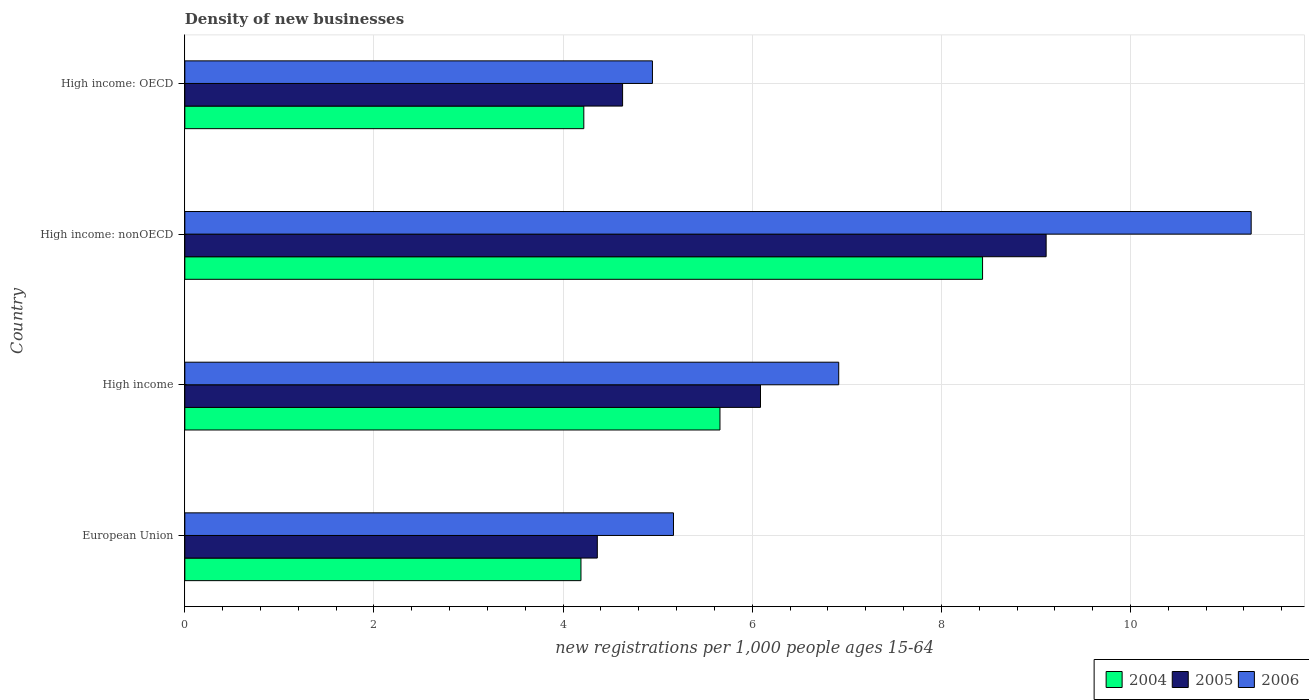Are the number of bars per tick equal to the number of legend labels?
Offer a very short reply. Yes. Are the number of bars on each tick of the Y-axis equal?
Keep it short and to the point. Yes. How many bars are there on the 1st tick from the top?
Provide a short and direct response. 3. What is the label of the 4th group of bars from the top?
Your answer should be very brief. European Union. In how many cases, is the number of bars for a given country not equal to the number of legend labels?
Your answer should be very brief. 0. What is the number of new registrations in 2006 in High income: OECD?
Offer a terse response. 4.94. Across all countries, what is the maximum number of new registrations in 2004?
Give a very brief answer. 8.44. Across all countries, what is the minimum number of new registrations in 2005?
Keep it short and to the point. 4.36. In which country was the number of new registrations in 2004 maximum?
Offer a very short reply. High income: nonOECD. In which country was the number of new registrations in 2004 minimum?
Your answer should be very brief. European Union. What is the total number of new registrations in 2004 in the graph?
Offer a terse response. 22.5. What is the difference between the number of new registrations in 2006 in European Union and that in High income: nonOECD?
Ensure brevity in your answer.  -6.11. What is the difference between the number of new registrations in 2004 in High income: OECD and the number of new registrations in 2005 in High income: nonOECD?
Make the answer very short. -4.89. What is the average number of new registrations in 2004 per country?
Offer a terse response. 5.63. What is the difference between the number of new registrations in 2006 and number of new registrations in 2005 in High income?
Your answer should be compact. 0.83. What is the ratio of the number of new registrations in 2005 in European Union to that in High income: OECD?
Ensure brevity in your answer.  0.94. Is the number of new registrations in 2004 in High income: OECD less than that in High income: nonOECD?
Ensure brevity in your answer.  Yes. What is the difference between the highest and the second highest number of new registrations in 2006?
Ensure brevity in your answer.  4.36. What is the difference between the highest and the lowest number of new registrations in 2006?
Your answer should be compact. 6.33. How many bars are there?
Offer a terse response. 12. Does the graph contain any zero values?
Ensure brevity in your answer.  No. How many legend labels are there?
Offer a terse response. 3. What is the title of the graph?
Give a very brief answer. Density of new businesses. Does "1963" appear as one of the legend labels in the graph?
Offer a terse response. No. What is the label or title of the X-axis?
Provide a short and direct response. New registrations per 1,0 people ages 15-64. What is the new registrations per 1,000 people ages 15-64 in 2004 in European Union?
Your response must be concise. 4.19. What is the new registrations per 1,000 people ages 15-64 in 2005 in European Union?
Provide a short and direct response. 4.36. What is the new registrations per 1,000 people ages 15-64 of 2006 in European Union?
Your answer should be very brief. 5.17. What is the new registrations per 1,000 people ages 15-64 of 2004 in High income?
Your answer should be very brief. 5.66. What is the new registrations per 1,000 people ages 15-64 of 2005 in High income?
Keep it short and to the point. 6.09. What is the new registrations per 1,000 people ages 15-64 in 2006 in High income?
Ensure brevity in your answer.  6.91. What is the new registrations per 1,000 people ages 15-64 of 2004 in High income: nonOECD?
Ensure brevity in your answer.  8.44. What is the new registrations per 1,000 people ages 15-64 of 2005 in High income: nonOECD?
Your response must be concise. 9.11. What is the new registrations per 1,000 people ages 15-64 in 2006 in High income: nonOECD?
Your answer should be compact. 11.28. What is the new registrations per 1,000 people ages 15-64 of 2004 in High income: OECD?
Give a very brief answer. 4.22. What is the new registrations per 1,000 people ages 15-64 of 2005 in High income: OECD?
Your answer should be very brief. 4.63. What is the new registrations per 1,000 people ages 15-64 in 2006 in High income: OECD?
Keep it short and to the point. 4.94. Across all countries, what is the maximum new registrations per 1,000 people ages 15-64 in 2004?
Your answer should be very brief. 8.44. Across all countries, what is the maximum new registrations per 1,000 people ages 15-64 in 2005?
Make the answer very short. 9.11. Across all countries, what is the maximum new registrations per 1,000 people ages 15-64 of 2006?
Provide a short and direct response. 11.28. Across all countries, what is the minimum new registrations per 1,000 people ages 15-64 in 2004?
Provide a succinct answer. 4.19. Across all countries, what is the minimum new registrations per 1,000 people ages 15-64 of 2005?
Make the answer very short. 4.36. Across all countries, what is the minimum new registrations per 1,000 people ages 15-64 of 2006?
Make the answer very short. 4.94. What is the total new registrations per 1,000 people ages 15-64 in 2004 in the graph?
Give a very brief answer. 22.5. What is the total new registrations per 1,000 people ages 15-64 of 2005 in the graph?
Provide a short and direct response. 24.19. What is the total new registrations per 1,000 people ages 15-64 of 2006 in the graph?
Provide a succinct answer. 28.3. What is the difference between the new registrations per 1,000 people ages 15-64 in 2004 in European Union and that in High income?
Your response must be concise. -1.47. What is the difference between the new registrations per 1,000 people ages 15-64 in 2005 in European Union and that in High income?
Provide a short and direct response. -1.73. What is the difference between the new registrations per 1,000 people ages 15-64 of 2006 in European Union and that in High income?
Give a very brief answer. -1.75. What is the difference between the new registrations per 1,000 people ages 15-64 of 2004 in European Union and that in High income: nonOECD?
Your answer should be compact. -4.25. What is the difference between the new registrations per 1,000 people ages 15-64 in 2005 in European Union and that in High income: nonOECD?
Offer a very short reply. -4.75. What is the difference between the new registrations per 1,000 people ages 15-64 of 2006 in European Union and that in High income: nonOECD?
Your answer should be compact. -6.11. What is the difference between the new registrations per 1,000 people ages 15-64 of 2004 in European Union and that in High income: OECD?
Make the answer very short. -0.03. What is the difference between the new registrations per 1,000 people ages 15-64 in 2005 in European Union and that in High income: OECD?
Keep it short and to the point. -0.27. What is the difference between the new registrations per 1,000 people ages 15-64 of 2006 in European Union and that in High income: OECD?
Your response must be concise. 0.22. What is the difference between the new registrations per 1,000 people ages 15-64 in 2004 in High income and that in High income: nonOECD?
Ensure brevity in your answer.  -2.78. What is the difference between the new registrations per 1,000 people ages 15-64 in 2005 in High income and that in High income: nonOECD?
Make the answer very short. -3.02. What is the difference between the new registrations per 1,000 people ages 15-64 in 2006 in High income and that in High income: nonOECD?
Give a very brief answer. -4.36. What is the difference between the new registrations per 1,000 people ages 15-64 of 2004 in High income and that in High income: OECD?
Offer a terse response. 1.44. What is the difference between the new registrations per 1,000 people ages 15-64 of 2005 in High income and that in High income: OECD?
Give a very brief answer. 1.46. What is the difference between the new registrations per 1,000 people ages 15-64 in 2006 in High income and that in High income: OECD?
Give a very brief answer. 1.97. What is the difference between the new registrations per 1,000 people ages 15-64 of 2004 in High income: nonOECD and that in High income: OECD?
Provide a short and direct response. 4.22. What is the difference between the new registrations per 1,000 people ages 15-64 in 2005 in High income: nonOECD and that in High income: OECD?
Offer a terse response. 4.48. What is the difference between the new registrations per 1,000 people ages 15-64 of 2006 in High income: nonOECD and that in High income: OECD?
Your answer should be very brief. 6.33. What is the difference between the new registrations per 1,000 people ages 15-64 of 2004 in European Union and the new registrations per 1,000 people ages 15-64 of 2005 in High income?
Provide a short and direct response. -1.9. What is the difference between the new registrations per 1,000 people ages 15-64 in 2004 in European Union and the new registrations per 1,000 people ages 15-64 in 2006 in High income?
Offer a very short reply. -2.73. What is the difference between the new registrations per 1,000 people ages 15-64 of 2005 in European Union and the new registrations per 1,000 people ages 15-64 of 2006 in High income?
Provide a succinct answer. -2.55. What is the difference between the new registrations per 1,000 people ages 15-64 of 2004 in European Union and the new registrations per 1,000 people ages 15-64 of 2005 in High income: nonOECD?
Your answer should be very brief. -4.92. What is the difference between the new registrations per 1,000 people ages 15-64 of 2004 in European Union and the new registrations per 1,000 people ages 15-64 of 2006 in High income: nonOECD?
Provide a succinct answer. -7.09. What is the difference between the new registrations per 1,000 people ages 15-64 in 2005 in European Union and the new registrations per 1,000 people ages 15-64 in 2006 in High income: nonOECD?
Provide a succinct answer. -6.91. What is the difference between the new registrations per 1,000 people ages 15-64 in 2004 in European Union and the new registrations per 1,000 people ages 15-64 in 2005 in High income: OECD?
Ensure brevity in your answer.  -0.44. What is the difference between the new registrations per 1,000 people ages 15-64 in 2004 in European Union and the new registrations per 1,000 people ages 15-64 in 2006 in High income: OECD?
Provide a short and direct response. -0.76. What is the difference between the new registrations per 1,000 people ages 15-64 in 2005 in European Union and the new registrations per 1,000 people ages 15-64 in 2006 in High income: OECD?
Your answer should be very brief. -0.58. What is the difference between the new registrations per 1,000 people ages 15-64 of 2004 in High income and the new registrations per 1,000 people ages 15-64 of 2005 in High income: nonOECD?
Your answer should be very brief. -3.45. What is the difference between the new registrations per 1,000 people ages 15-64 in 2004 in High income and the new registrations per 1,000 people ages 15-64 in 2006 in High income: nonOECD?
Your answer should be compact. -5.62. What is the difference between the new registrations per 1,000 people ages 15-64 of 2005 in High income and the new registrations per 1,000 people ages 15-64 of 2006 in High income: nonOECD?
Keep it short and to the point. -5.19. What is the difference between the new registrations per 1,000 people ages 15-64 of 2004 in High income and the new registrations per 1,000 people ages 15-64 of 2005 in High income: OECD?
Keep it short and to the point. 1.03. What is the difference between the new registrations per 1,000 people ages 15-64 in 2004 in High income and the new registrations per 1,000 people ages 15-64 in 2006 in High income: OECD?
Offer a terse response. 0.71. What is the difference between the new registrations per 1,000 people ages 15-64 of 2005 in High income and the new registrations per 1,000 people ages 15-64 of 2006 in High income: OECD?
Give a very brief answer. 1.14. What is the difference between the new registrations per 1,000 people ages 15-64 in 2004 in High income: nonOECD and the new registrations per 1,000 people ages 15-64 in 2005 in High income: OECD?
Your response must be concise. 3.81. What is the difference between the new registrations per 1,000 people ages 15-64 in 2004 in High income: nonOECD and the new registrations per 1,000 people ages 15-64 in 2006 in High income: OECD?
Make the answer very short. 3.49. What is the difference between the new registrations per 1,000 people ages 15-64 in 2005 in High income: nonOECD and the new registrations per 1,000 people ages 15-64 in 2006 in High income: OECD?
Offer a very short reply. 4.16. What is the average new registrations per 1,000 people ages 15-64 in 2004 per country?
Your answer should be compact. 5.63. What is the average new registrations per 1,000 people ages 15-64 of 2005 per country?
Offer a very short reply. 6.05. What is the average new registrations per 1,000 people ages 15-64 of 2006 per country?
Keep it short and to the point. 7.08. What is the difference between the new registrations per 1,000 people ages 15-64 in 2004 and new registrations per 1,000 people ages 15-64 in 2005 in European Union?
Give a very brief answer. -0.17. What is the difference between the new registrations per 1,000 people ages 15-64 in 2004 and new registrations per 1,000 people ages 15-64 in 2006 in European Union?
Offer a terse response. -0.98. What is the difference between the new registrations per 1,000 people ages 15-64 of 2005 and new registrations per 1,000 people ages 15-64 of 2006 in European Union?
Offer a very short reply. -0.81. What is the difference between the new registrations per 1,000 people ages 15-64 of 2004 and new registrations per 1,000 people ages 15-64 of 2005 in High income?
Offer a terse response. -0.43. What is the difference between the new registrations per 1,000 people ages 15-64 in 2004 and new registrations per 1,000 people ages 15-64 in 2006 in High income?
Provide a succinct answer. -1.26. What is the difference between the new registrations per 1,000 people ages 15-64 of 2005 and new registrations per 1,000 people ages 15-64 of 2006 in High income?
Provide a short and direct response. -0.83. What is the difference between the new registrations per 1,000 people ages 15-64 of 2004 and new registrations per 1,000 people ages 15-64 of 2005 in High income: nonOECD?
Your answer should be compact. -0.67. What is the difference between the new registrations per 1,000 people ages 15-64 of 2004 and new registrations per 1,000 people ages 15-64 of 2006 in High income: nonOECD?
Your response must be concise. -2.84. What is the difference between the new registrations per 1,000 people ages 15-64 in 2005 and new registrations per 1,000 people ages 15-64 in 2006 in High income: nonOECD?
Keep it short and to the point. -2.17. What is the difference between the new registrations per 1,000 people ages 15-64 in 2004 and new registrations per 1,000 people ages 15-64 in 2005 in High income: OECD?
Keep it short and to the point. -0.41. What is the difference between the new registrations per 1,000 people ages 15-64 of 2004 and new registrations per 1,000 people ages 15-64 of 2006 in High income: OECD?
Make the answer very short. -0.73. What is the difference between the new registrations per 1,000 people ages 15-64 in 2005 and new registrations per 1,000 people ages 15-64 in 2006 in High income: OECD?
Your answer should be very brief. -0.32. What is the ratio of the new registrations per 1,000 people ages 15-64 of 2004 in European Union to that in High income?
Offer a terse response. 0.74. What is the ratio of the new registrations per 1,000 people ages 15-64 of 2005 in European Union to that in High income?
Offer a terse response. 0.72. What is the ratio of the new registrations per 1,000 people ages 15-64 in 2006 in European Union to that in High income?
Your answer should be compact. 0.75. What is the ratio of the new registrations per 1,000 people ages 15-64 of 2004 in European Union to that in High income: nonOECD?
Provide a short and direct response. 0.5. What is the ratio of the new registrations per 1,000 people ages 15-64 of 2005 in European Union to that in High income: nonOECD?
Provide a short and direct response. 0.48. What is the ratio of the new registrations per 1,000 people ages 15-64 in 2006 in European Union to that in High income: nonOECD?
Your answer should be compact. 0.46. What is the ratio of the new registrations per 1,000 people ages 15-64 of 2004 in European Union to that in High income: OECD?
Ensure brevity in your answer.  0.99. What is the ratio of the new registrations per 1,000 people ages 15-64 in 2005 in European Union to that in High income: OECD?
Ensure brevity in your answer.  0.94. What is the ratio of the new registrations per 1,000 people ages 15-64 of 2006 in European Union to that in High income: OECD?
Offer a very short reply. 1.04. What is the ratio of the new registrations per 1,000 people ages 15-64 of 2004 in High income to that in High income: nonOECD?
Keep it short and to the point. 0.67. What is the ratio of the new registrations per 1,000 people ages 15-64 of 2005 in High income to that in High income: nonOECD?
Provide a succinct answer. 0.67. What is the ratio of the new registrations per 1,000 people ages 15-64 in 2006 in High income to that in High income: nonOECD?
Give a very brief answer. 0.61. What is the ratio of the new registrations per 1,000 people ages 15-64 in 2004 in High income to that in High income: OECD?
Provide a short and direct response. 1.34. What is the ratio of the new registrations per 1,000 people ages 15-64 of 2005 in High income to that in High income: OECD?
Give a very brief answer. 1.31. What is the ratio of the new registrations per 1,000 people ages 15-64 in 2006 in High income to that in High income: OECD?
Provide a short and direct response. 1.4. What is the ratio of the new registrations per 1,000 people ages 15-64 in 2004 in High income: nonOECD to that in High income: OECD?
Provide a short and direct response. 2. What is the ratio of the new registrations per 1,000 people ages 15-64 of 2005 in High income: nonOECD to that in High income: OECD?
Keep it short and to the point. 1.97. What is the ratio of the new registrations per 1,000 people ages 15-64 in 2006 in High income: nonOECD to that in High income: OECD?
Ensure brevity in your answer.  2.28. What is the difference between the highest and the second highest new registrations per 1,000 people ages 15-64 in 2004?
Ensure brevity in your answer.  2.78. What is the difference between the highest and the second highest new registrations per 1,000 people ages 15-64 of 2005?
Ensure brevity in your answer.  3.02. What is the difference between the highest and the second highest new registrations per 1,000 people ages 15-64 of 2006?
Your answer should be very brief. 4.36. What is the difference between the highest and the lowest new registrations per 1,000 people ages 15-64 in 2004?
Offer a very short reply. 4.25. What is the difference between the highest and the lowest new registrations per 1,000 people ages 15-64 in 2005?
Your answer should be compact. 4.75. What is the difference between the highest and the lowest new registrations per 1,000 people ages 15-64 in 2006?
Provide a short and direct response. 6.33. 